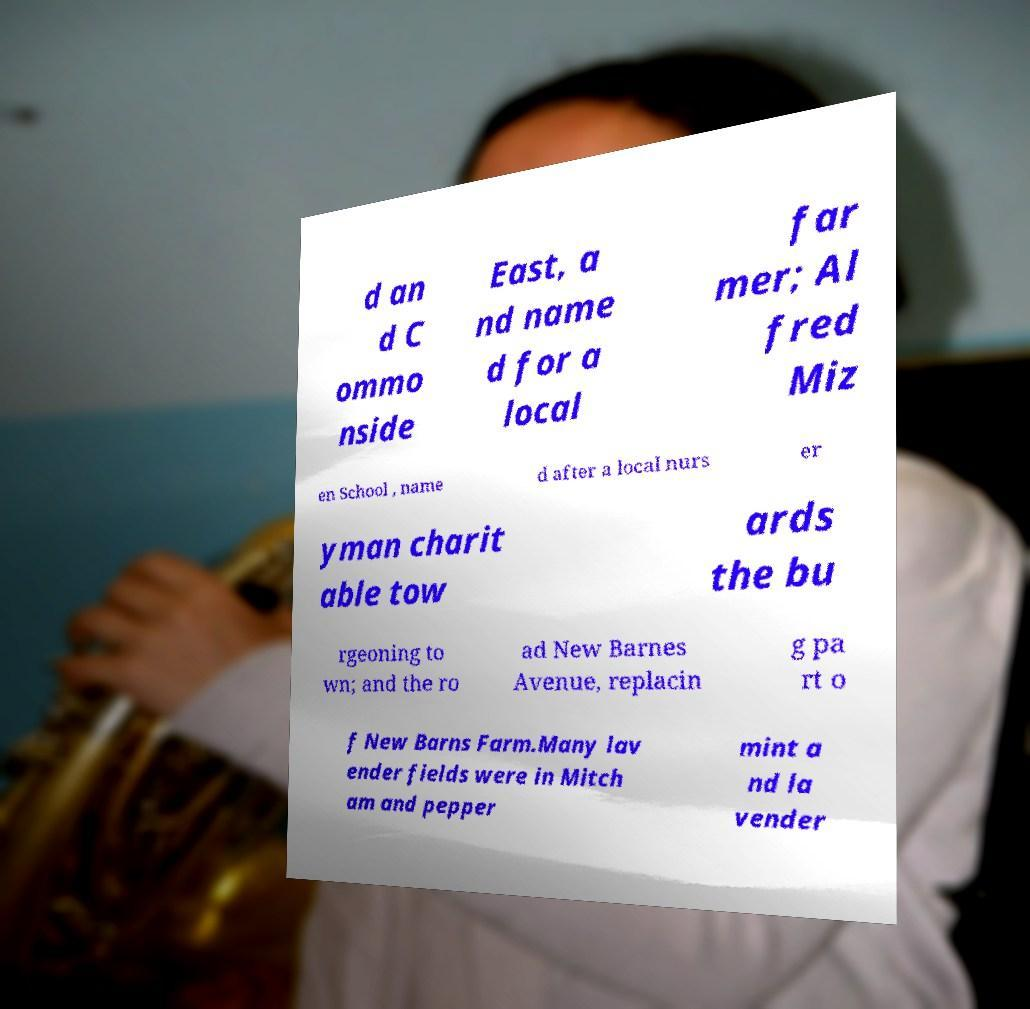There's text embedded in this image that I need extracted. Can you transcribe it verbatim? d an d C ommo nside East, a nd name d for a local far mer; Al fred Miz en School , name d after a local nurs er yman charit able tow ards the bu rgeoning to wn; and the ro ad New Barnes Avenue, replacin g pa rt o f New Barns Farm.Many lav ender fields were in Mitch am and pepper mint a nd la vender 